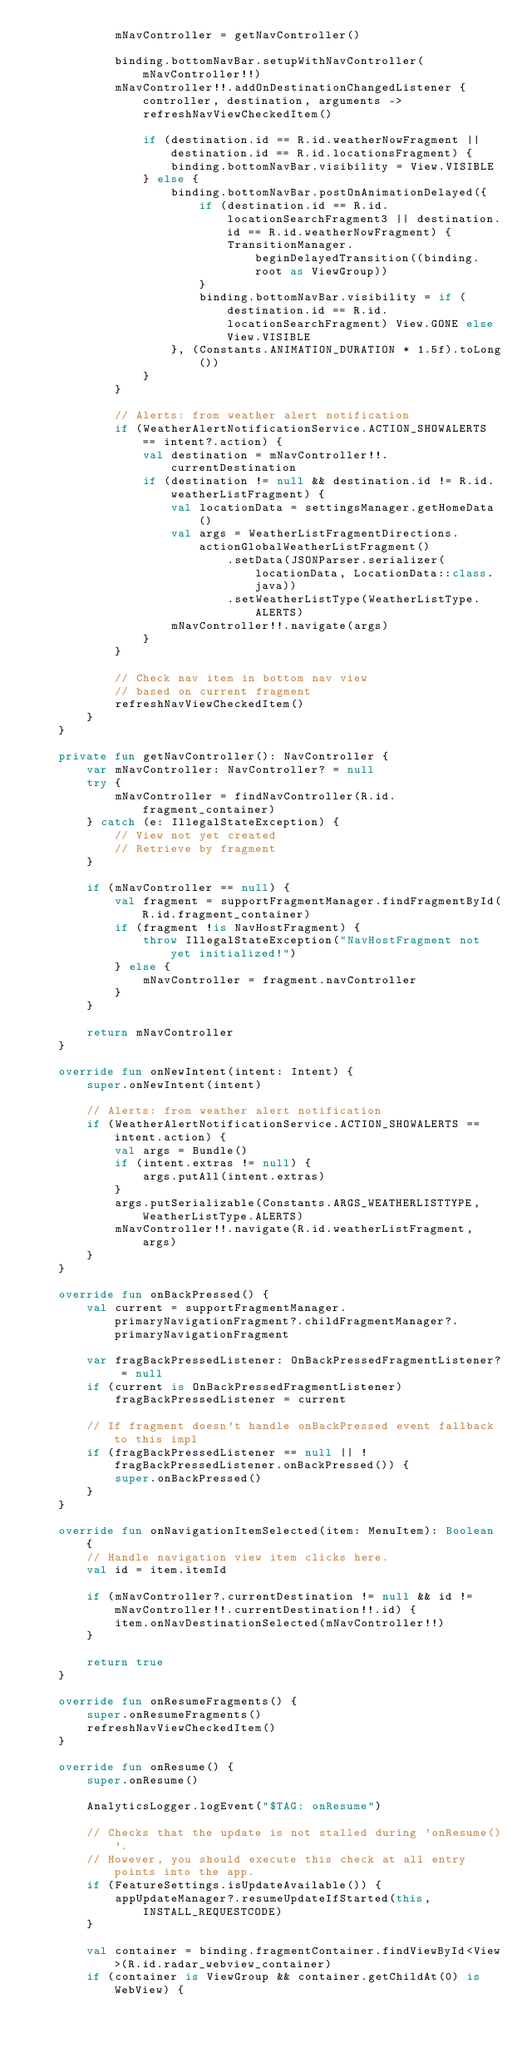Convert code to text. <code><loc_0><loc_0><loc_500><loc_500><_Kotlin_>            mNavController = getNavController()

            binding.bottomNavBar.setupWithNavController(mNavController!!)
            mNavController!!.addOnDestinationChangedListener { controller, destination, arguments ->
                refreshNavViewCheckedItem()

                if (destination.id == R.id.weatherNowFragment || destination.id == R.id.locationsFragment) {
                    binding.bottomNavBar.visibility = View.VISIBLE
                } else {
                    binding.bottomNavBar.postOnAnimationDelayed({
                        if (destination.id == R.id.locationSearchFragment3 || destination.id == R.id.weatherNowFragment) {
                            TransitionManager.beginDelayedTransition((binding.root as ViewGroup))
                        }
                        binding.bottomNavBar.visibility = if (destination.id == R.id.locationSearchFragment) View.GONE else View.VISIBLE
                    }, (Constants.ANIMATION_DURATION * 1.5f).toLong())
                }
            }

            // Alerts: from weather alert notification
            if (WeatherAlertNotificationService.ACTION_SHOWALERTS == intent?.action) {
                val destination = mNavController!!.currentDestination
                if (destination != null && destination.id != R.id.weatherListFragment) {
                    val locationData = settingsManager.getHomeData()
                    val args = WeatherListFragmentDirections.actionGlobalWeatherListFragment()
                            .setData(JSONParser.serializer(locationData, LocationData::class.java))
                            .setWeatherListType(WeatherListType.ALERTS)
                    mNavController!!.navigate(args)
                }
            }

            // Check nav item in bottom nav view
            // based on current fragment
            refreshNavViewCheckedItem()
        }
    }

    private fun getNavController(): NavController {
        var mNavController: NavController? = null
        try {
            mNavController = findNavController(R.id.fragment_container)
        } catch (e: IllegalStateException) {
            // View not yet created
            // Retrieve by fragment
        }

        if (mNavController == null) {
            val fragment = supportFragmentManager.findFragmentById(R.id.fragment_container)
            if (fragment !is NavHostFragment) {
                throw IllegalStateException("NavHostFragment not yet initialized!")
            } else {
                mNavController = fragment.navController
            }
        }

        return mNavController
    }

    override fun onNewIntent(intent: Intent) {
        super.onNewIntent(intent)

        // Alerts: from weather alert notification
        if (WeatherAlertNotificationService.ACTION_SHOWALERTS == intent.action) {
            val args = Bundle()
            if (intent.extras != null) {
                args.putAll(intent.extras)
            }
            args.putSerializable(Constants.ARGS_WEATHERLISTTYPE, WeatherListType.ALERTS)
            mNavController!!.navigate(R.id.weatherListFragment, args)
        }
    }

    override fun onBackPressed() {
        val current = supportFragmentManager.primaryNavigationFragment?.childFragmentManager?.primaryNavigationFragment

        var fragBackPressedListener: OnBackPressedFragmentListener? = null
        if (current is OnBackPressedFragmentListener)
            fragBackPressedListener = current

        // If fragment doesn't handle onBackPressed event fallback to this impl
        if (fragBackPressedListener == null || !fragBackPressedListener.onBackPressed()) {
            super.onBackPressed()
        }
    }

    override fun onNavigationItemSelected(item: MenuItem): Boolean {
        // Handle navigation view item clicks here.
        val id = item.itemId

        if (mNavController?.currentDestination != null && id != mNavController!!.currentDestination!!.id) {
            item.onNavDestinationSelected(mNavController!!)
        }

        return true
    }

    override fun onResumeFragments() {
        super.onResumeFragments()
        refreshNavViewCheckedItem()
    }

    override fun onResume() {
        super.onResume()

        AnalyticsLogger.logEvent("$TAG: onResume")

        // Checks that the update is not stalled during 'onResume()'.
        // However, you should execute this check at all entry points into the app.
        if (FeatureSettings.isUpdateAvailable()) {
            appUpdateManager?.resumeUpdateIfStarted(this, INSTALL_REQUESTCODE)
        }

        val container = binding.fragmentContainer.findViewById<View>(R.id.radar_webview_container)
        if (container is ViewGroup && container.getChildAt(0) is WebView) {</code> 